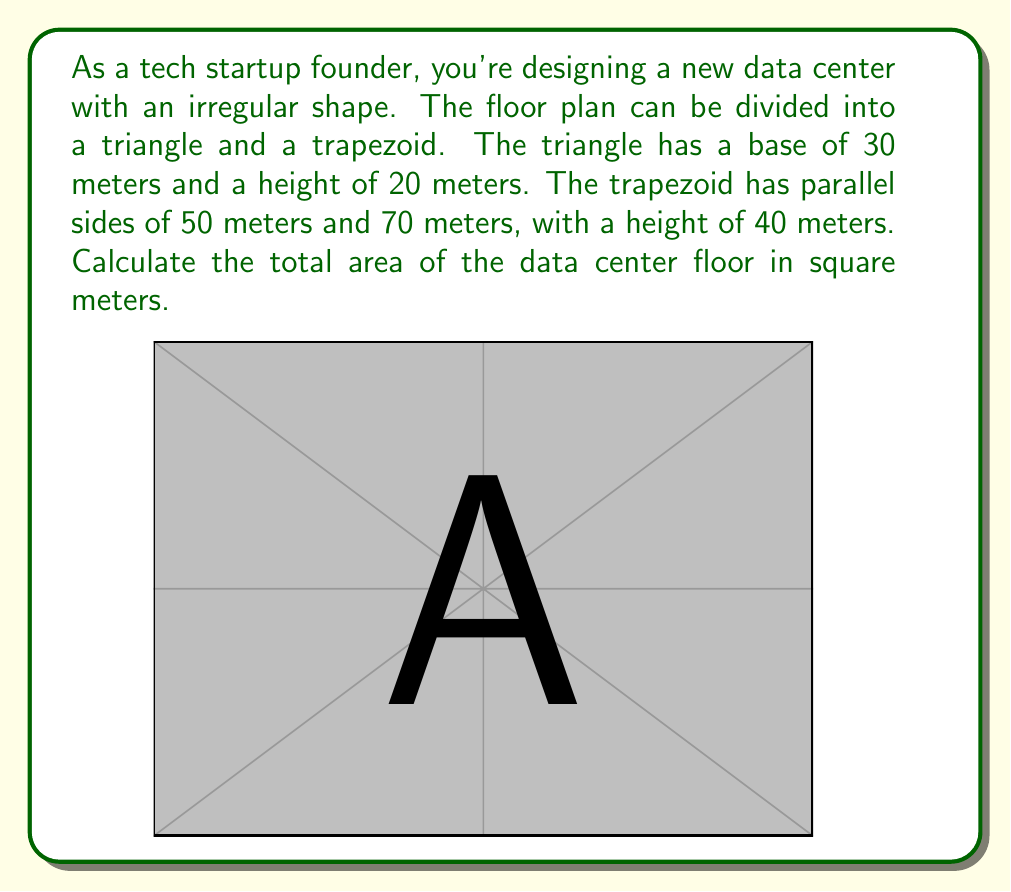Could you help me with this problem? Let's break this down step-by-step:

1) First, we'll calculate the area of the triangle:
   The formula for the area of a triangle is: $A_{triangle} = \frac{1}{2} \times base \times height$
   $$A_{triangle} = \frac{1}{2} \times 30 \times 20 = 300 \text{ m}^2$$

2) Next, we'll calculate the area of the trapezoid:
   The formula for the area of a trapezoid is: $A_{trapezoid} = \frac{a+b}{2} \times h$
   Where $a$ and $b$ are the parallel sides and $h$ is the height.
   $$A_{trapezoid} = \frac{50+70}{2} \times 40 = 60 \times 40 = 2400 \text{ m}^2$$

3) The total area is the sum of these two areas:
   $$A_{total} = A_{triangle} + A_{trapezoid} = 300 + 2400 = 2700 \text{ m}^2$$

Therefore, the total area of the data center floor is 2700 square meters.
Answer: 2700 m² 